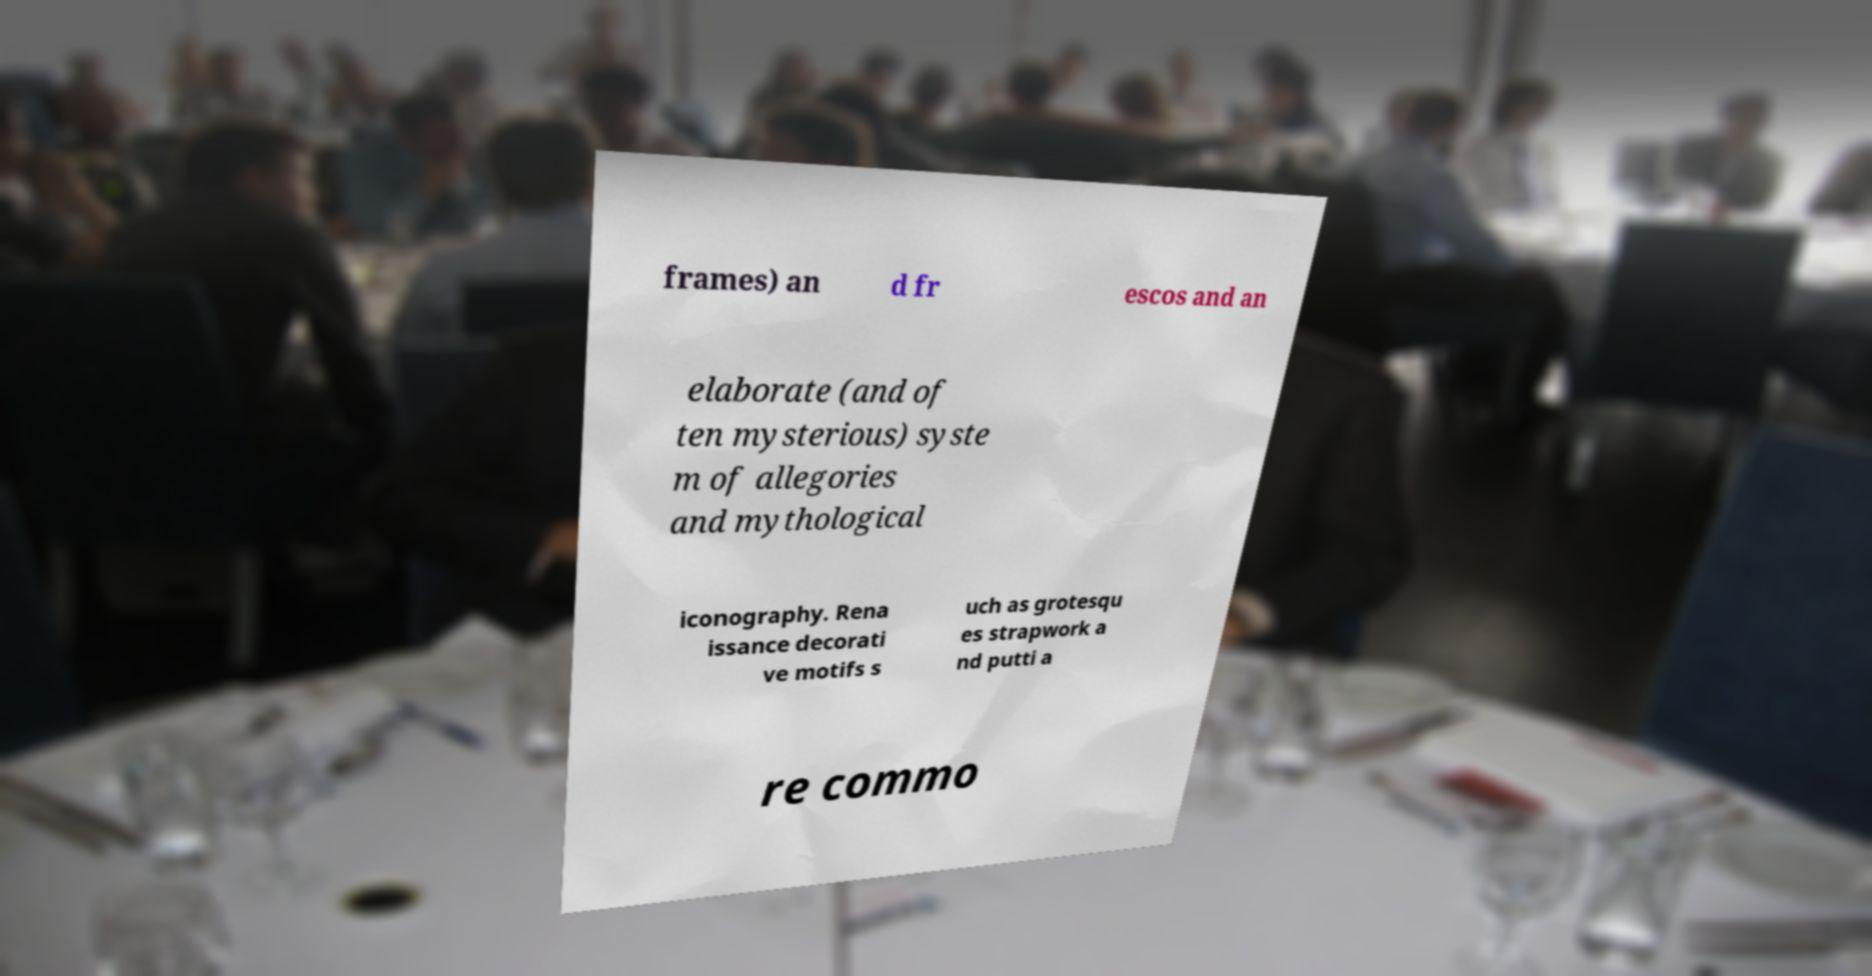Please identify and transcribe the text found in this image. frames) an d fr escos and an elaborate (and of ten mysterious) syste m of allegories and mythological iconography. Rena issance decorati ve motifs s uch as grotesqu es strapwork a nd putti a re commo 